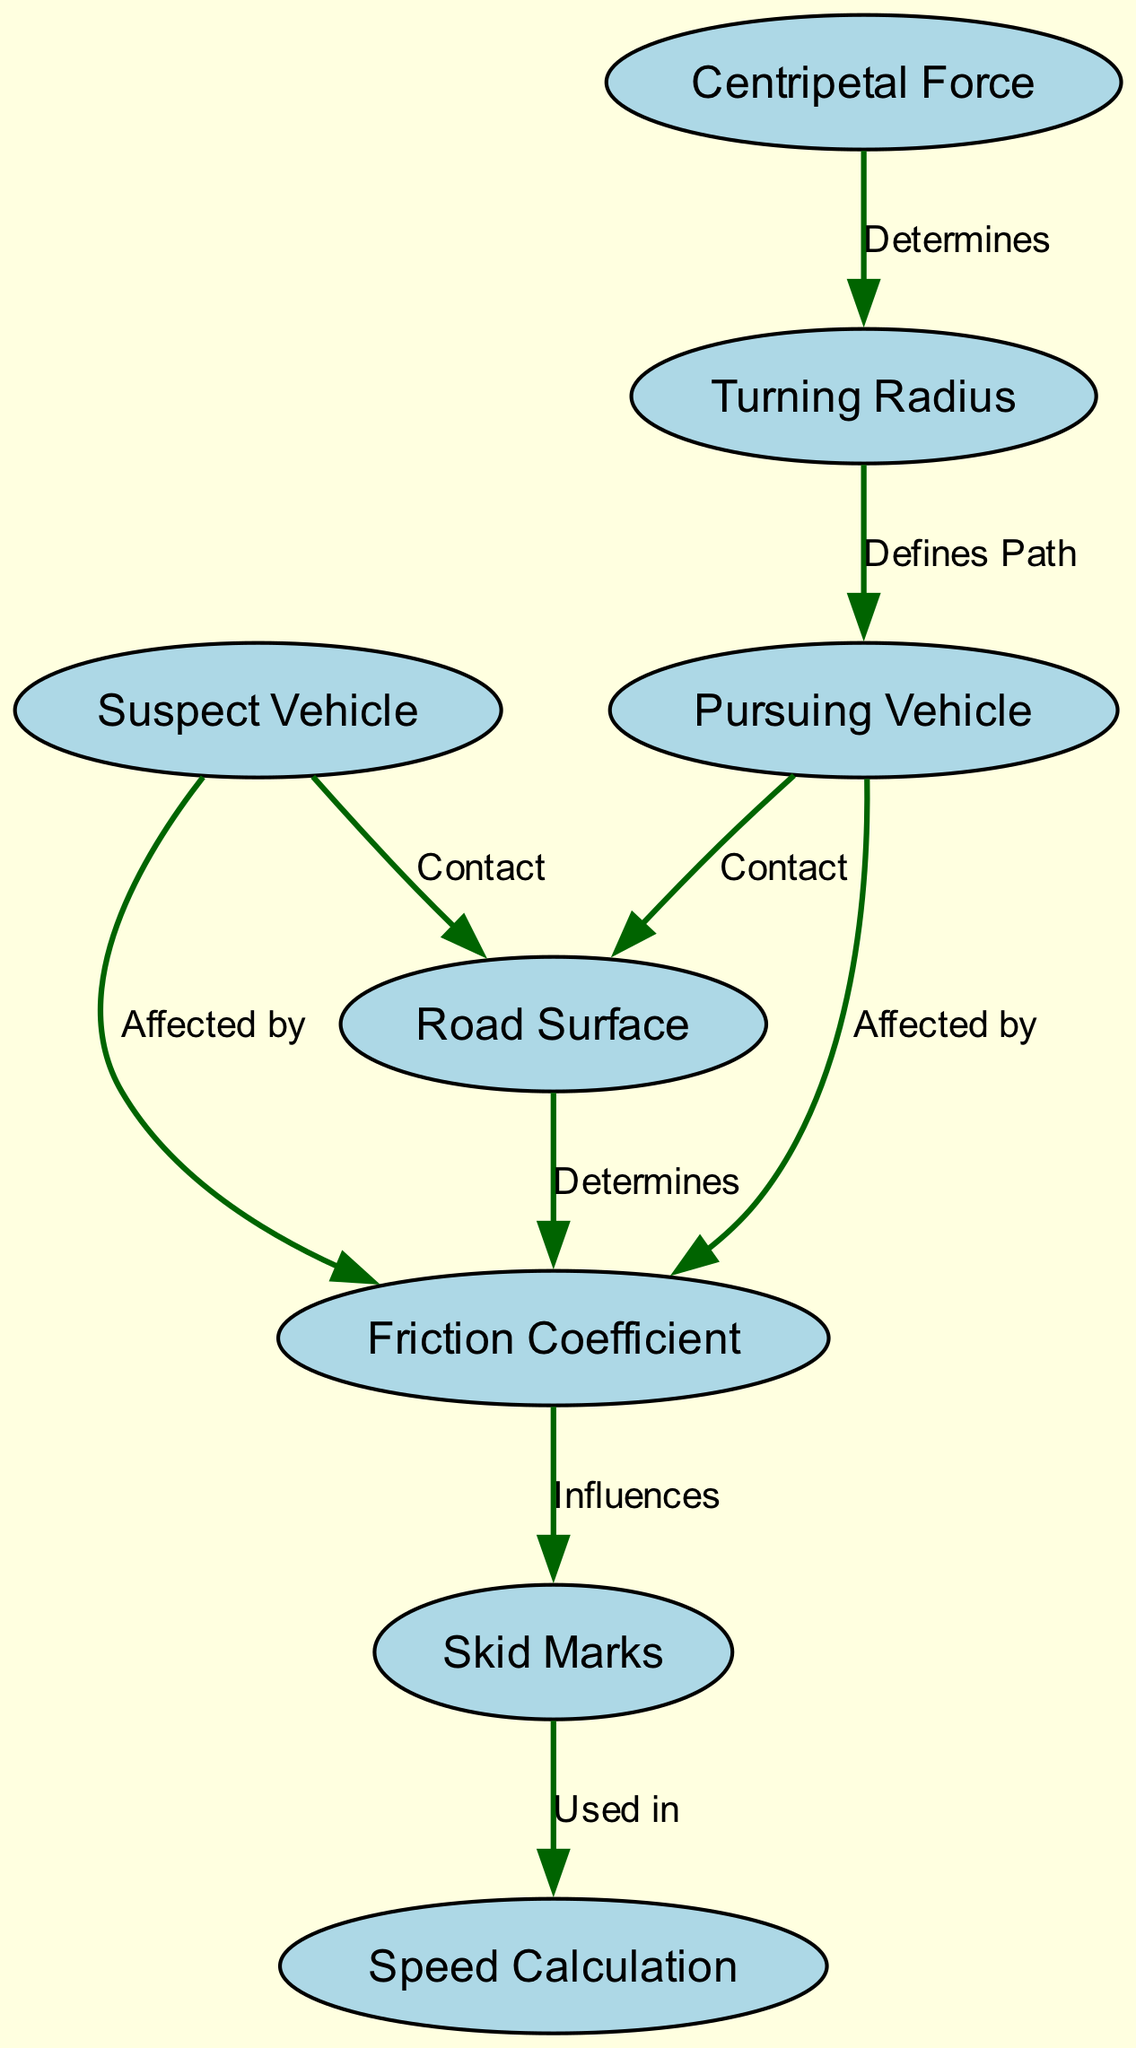What are the two types of vehicles shown in the diagram? The diagram displays two specific types of vehicles, which are the "Pursuing Vehicle" and the "Suspect Vehicle". These are labeled and identifiable in the nodes of the diagram.
Answer: Pursuing Vehicle, Suspect Vehicle How many nodes are in the diagram? By counting the entries in the nodes section of the data, we find that there are a total of eight nodes represented in the diagram.
Answer: Eight What influences the skid marks according to the diagram? From the edges of the diagram, it is clear that the "Friction Coefficient" is indicated as influencing the "Skid Marks". This relationship is explicitly labeled in the connections between these two nodes.
Answer: Friction Coefficient Which force determines the turning radius? The connection in the diagram shows that "Centripetal Force" is the force that determines the "Turning Radius". This relationship indicates that the centripetal force directly affects how tight a vehicle can turn.
Answer: Centripetal Force What is used to estimate speed from skid marks? The diagram states that "Speed Calculation" uses the "Skid Marks" as part of the process for estimating speed during the chases. This clearly indicates the role of skid marks in the speed analysis.
Answer: Speed Calculation How does the road surface affect the vehicles? Based on the diagram, both the "Pursuing Vehicle" and the "Suspect Vehicle" are shown to be affected by the "Friction Coefficient," which is determined by the "Road Surface". This indicates that the type of surface influences how vehicles interact with it.
Answer: Faction Coefficient What defines the path of the vehicle? The diagram illustrates that the "Turning Radius" defines the path of the "Pursuing Vehicle". This relationship indicates that how sharp the turn is will directly affect the trajectory of the vehicle in the chase.
Answer: Turning Radius 